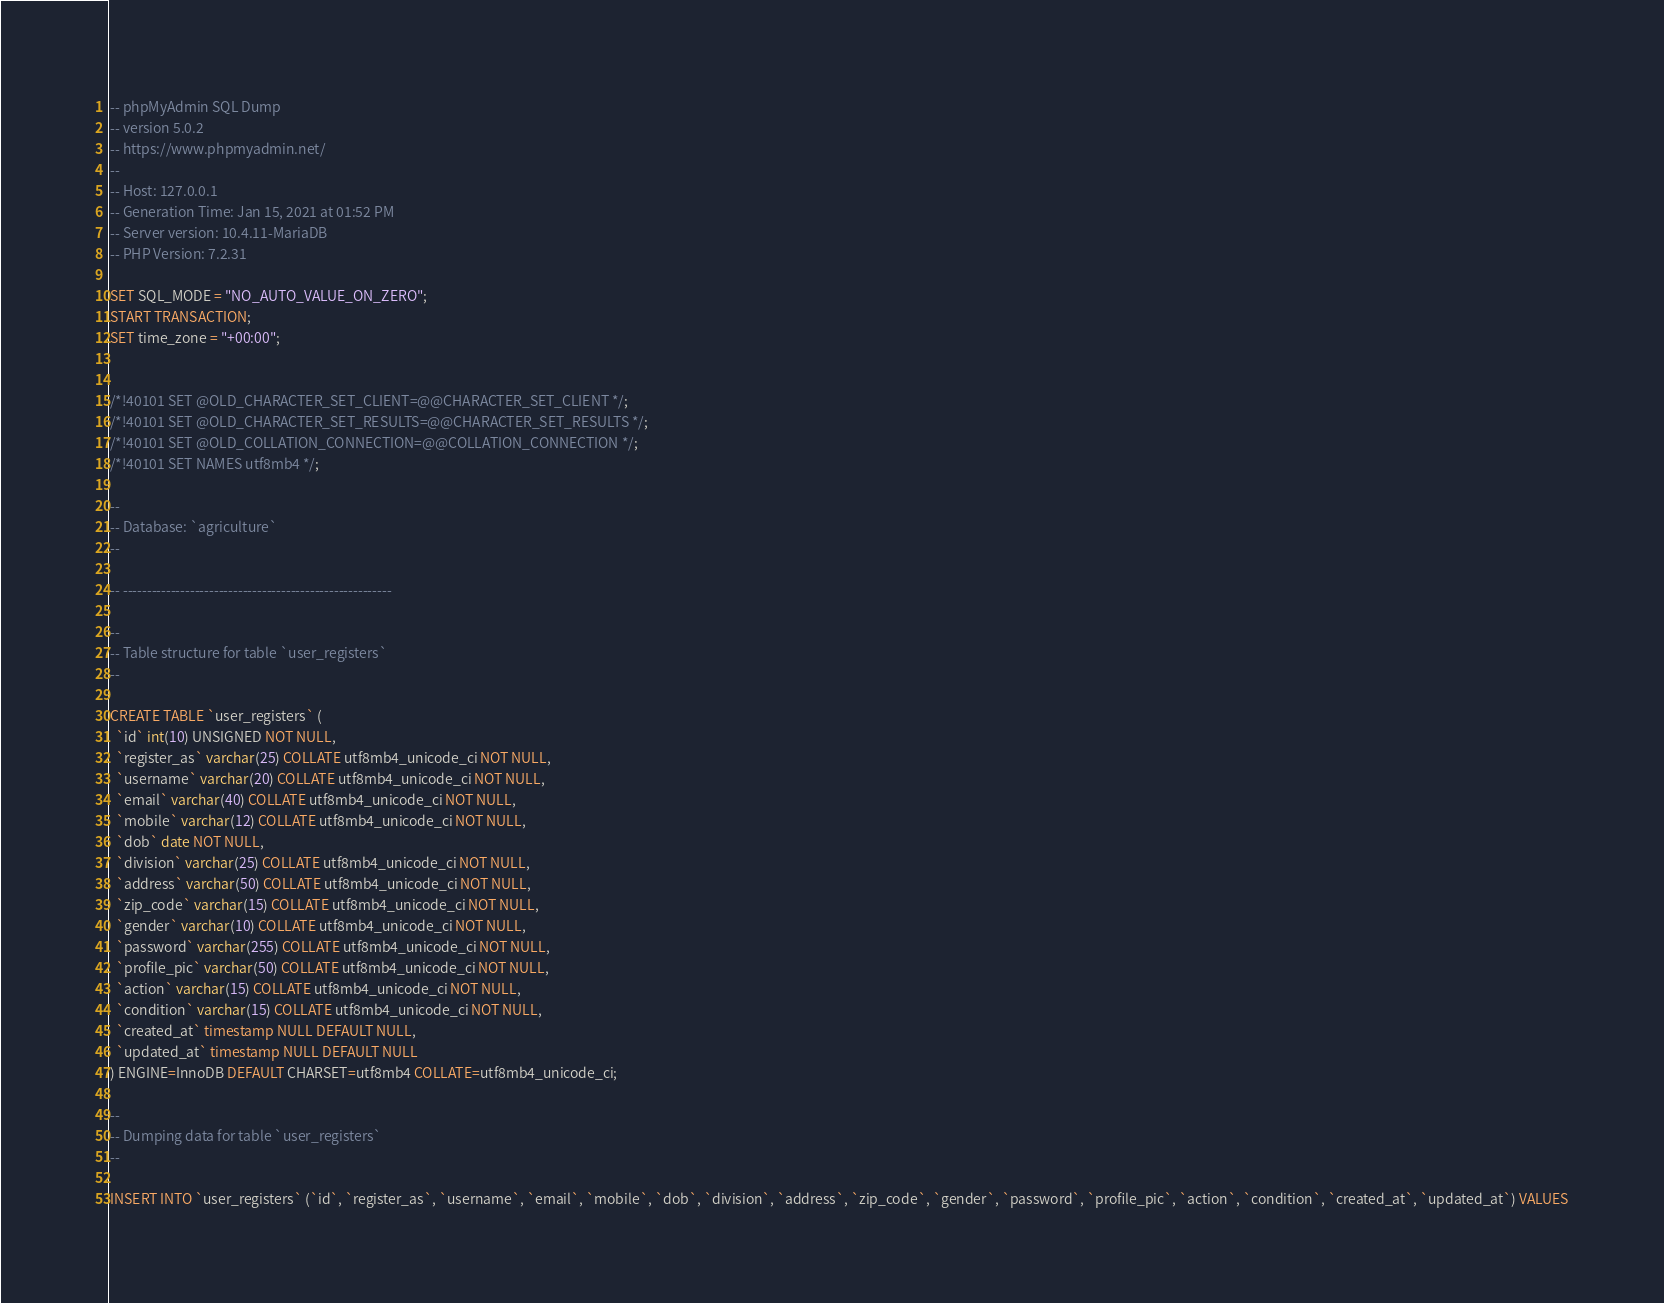<code> <loc_0><loc_0><loc_500><loc_500><_SQL_>-- phpMyAdmin SQL Dump
-- version 5.0.2
-- https://www.phpmyadmin.net/
--
-- Host: 127.0.0.1
-- Generation Time: Jan 15, 2021 at 01:52 PM
-- Server version: 10.4.11-MariaDB
-- PHP Version: 7.2.31

SET SQL_MODE = "NO_AUTO_VALUE_ON_ZERO";
START TRANSACTION;
SET time_zone = "+00:00";


/*!40101 SET @OLD_CHARACTER_SET_CLIENT=@@CHARACTER_SET_CLIENT */;
/*!40101 SET @OLD_CHARACTER_SET_RESULTS=@@CHARACTER_SET_RESULTS */;
/*!40101 SET @OLD_COLLATION_CONNECTION=@@COLLATION_CONNECTION */;
/*!40101 SET NAMES utf8mb4 */;

--
-- Database: `agriculture`
--

-- --------------------------------------------------------

--
-- Table structure for table `user_registers`
--

CREATE TABLE `user_registers` (
  `id` int(10) UNSIGNED NOT NULL,
  `register_as` varchar(25) COLLATE utf8mb4_unicode_ci NOT NULL,
  `username` varchar(20) COLLATE utf8mb4_unicode_ci NOT NULL,
  `email` varchar(40) COLLATE utf8mb4_unicode_ci NOT NULL,
  `mobile` varchar(12) COLLATE utf8mb4_unicode_ci NOT NULL,
  `dob` date NOT NULL,
  `division` varchar(25) COLLATE utf8mb4_unicode_ci NOT NULL,
  `address` varchar(50) COLLATE utf8mb4_unicode_ci NOT NULL,
  `zip_code` varchar(15) COLLATE utf8mb4_unicode_ci NOT NULL,
  `gender` varchar(10) COLLATE utf8mb4_unicode_ci NOT NULL,
  `password` varchar(255) COLLATE utf8mb4_unicode_ci NOT NULL,
  `profile_pic` varchar(50) COLLATE utf8mb4_unicode_ci NOT NULL,
  `action` varchar(15) COLLATE utf8mb4_unicode_ci NOT NULL,
  `condition` varchar(15) COLLATE utf8mb4_unicode_ci NOT NULL,
  `created_at` timestamp NULL DEFAULT NULL,
  `updated_at` timestamp NULL DEFAULT NULL
) ENGINE=InnoDB DEFAULT CHARSET=utf8mb4 COLLATE=utf8mb4_unicode_ci;

--
-- Dumping data for table `user_registers`
--

INSERT INTO `user_registers` (`id`, `register_as`, `username`, `email`, `mobile`, `dob`, `division`, `address`, `zip_code`, `gender`, `password`, `profile_pic`, `action`, `condition`, `created_at`, `updated_at`) VALUES</code> 